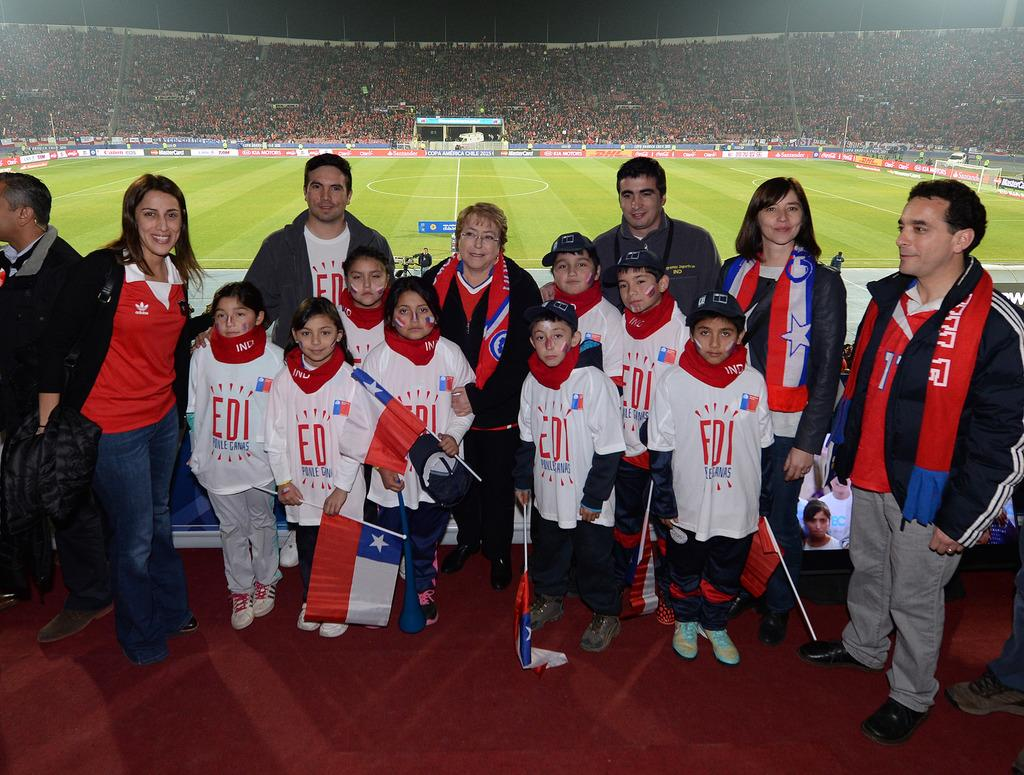<image>
Create a compact narrative representing the image presented. Group of children wearing "EDI" shirts posing for a picture. 